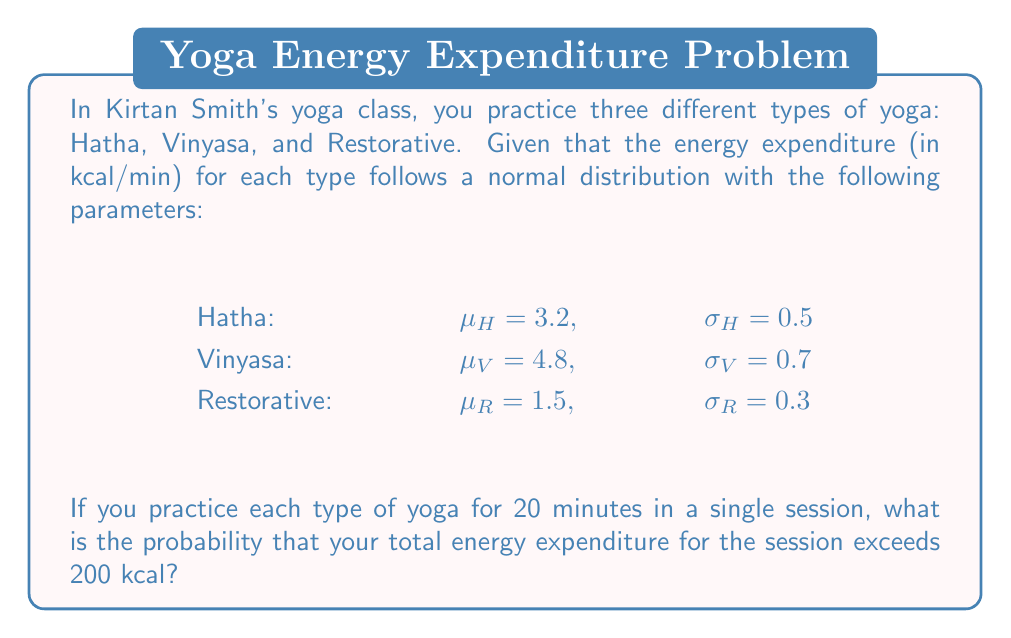What is the answer to this math problem? Let's approach this step-by-step:

1) First, we need to calculate the total energy expenditure for each type of yoga:

   For Hatha: $X_H \sim N(3.2 \cdot 20, (0.5 \cdot \sqrt{20})^2)$
   For Vinyasa: $X_V \sim N(4.8 \cdot 20, (0.7 \cdot \sqrt{20})^2)$
   For Restorative: $X_R \sim N(1.5 \cdot 20, (0.3 \cdot \sqrt{20})^2)$

2) The total energy expenditure $X = X_H + X_V + X_R$ will also follow a normal distribution. We need to find its mean and standard deviation:

   $\mu_X = (3.2 \cdot 20) + (4.8 \cdot 20) + (1.5 \cdot 20) = 64 + 96 + 30 = 190$

   $\sigma_X^2 = (0.5^2 \cdot 20) + (0.7^2 \cdot 20) + (0.3^2 \cdot 20) = 5 + 9.8 + 1.8 = 16.6$
   $\sigma_X = \sqrt{16.6} \approx 4.07$

3) So, $X \sim N(190, 4.07^2)$

4) We want to find $P(X > 200)$. We can standardize this:

   $Z = \frac{X - \mu}{\sigma} = \frac{200 - 190}{4.07} \approx 2.46$

5) We need to find $P(Z > 2.46)$. Using a standard normal table or calculator:

   $P(Z > 2.46) \approx 0.0069$

Therefore, the probability that the total energy expenditure exceeds 200 kcal is approximately 0.0069 or 0.69%.
Answer: 0.0069 (or 0.69%) 